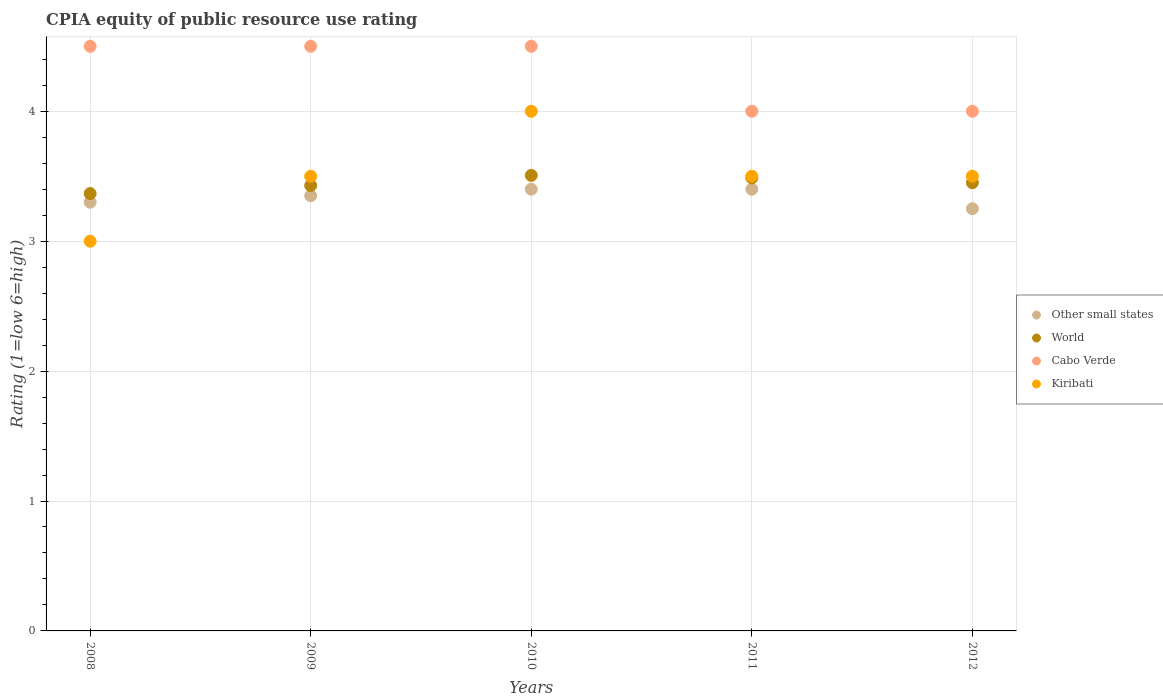Across all years, what is the minimum CPIA rating in Kiribati?
Your answer should be very brief. 3. In which year was the CPIA rating in Other small states minimum?
Make the answer very short. 2012. What is the total CPIA rating in World in the graph?
Offer a very short reply. 17.24. What is the difference between the CPIA rating in World in 2010 and that in 2012?
Make the answer very short. 0.06. What is the difference between the CPIA rating in World in 2010 and the CPIA rating in Kiribati in 2009?
Ensure brevity in your answer.  0.01. In the year 2009, what is the difference between the CPIA rating in World and CPIA rating in Other small states?
Keep it short and to the point. 0.08. In how many years, is the CPIA rating in Kiribati greater than 3.4?
Offer a terse response. 4. What is the ratio of the CPIA rating in Other small states in 2008 to that in 2011?
Provide a succinct answer. 0.97. What is the difference between the highest and the lowest CPIA rating in Cabo Verde?
Your answer should be compact. 0.5. In how many years, is the CPIA rating in Kiribati greater than the average CPIA rating in Kiribati taken over all years?
Give a very brief answer. 1. Is the sum of the CPIA rating in World in 2008 and 2012 greater than the maximum CPIA rating in Other small states across all years?
Your response must be concise. Yes. Is it the case that in every year, the sum of the CPIA rating in Other small states and CPIA rating in World  is greater than the sum of CPIA rating in Cabo Verde and CPIA rating in Kiribati?
Your response must be concise. No. Is it the case that in every year, the sum of the CPIA rating in World and CPIA rating in Kiribati  is greater than the CPIA rating in Other small states?
Your answer should be very brief. Yes. Does the CPIA rating in Kiribati monotonically increase over the years?
Your response must be concise. No. Is the CPIA rating in Other small states strictly greater than the CPIA rating in World over the years?
Your answer should be very brief. No. How many dotlines are there?
Provide a short and direct response. 4. What is the difference between two consecutive major ticks on the Y-axis?
Ensure brevity in your answer.  1. Are the values on the major ticks of Y-axis written in scientific E-notation?
Make the answer very short. No. Does the graph contain any zero values?
Your response must be concise. No. Does the graph contain grids?
Offer a very short reply. Yes. Where does the legend appear in the graph?
Provide a succinct answer. Center right. How are the legend labels stacked?
Your answer should be very brief. Vertical. What is the title of the graph?
Make the answer very short. CPIA equity of public resource use rating. Does "Angola" appear as one of the legend labels in the graph?
Offer a very short reply. No. What is the label or title of the X-axis?
Make the answer very short. Years. What is the label or title of the Y-axis?
Your response must be concise. Rating (1=low 6=high). What is the Rating (1=low 6=high) in World in 2008?
Provide a short and direct response. 3.37. What is the Rating (1=low 6=high) in Cabo Verde in 2008?
Keep it short and to the point. 4.5. What is the Rating (1=low 6=high) of Kiribati in 2008?
Keep it short and to the point. 3. What is the Rating (1=low 6=high) in Other small states in 2009?
Keep it short and to the point. 3.35. What is the Rating (1=low 6=high) of World in 2009?
Make the answer very short. 3.43. What is the Rating (1=low 6=high) in Cabo Verde in 2009?
Ensure brevity in your answer.  4.5. What is the Rating (1=low 6=high) of Other small states in 2010?
Provide a short and direct response. 3.4. What is the Rating (1=low 6=high) in World in 2010?
Offer a terse response. 3.51. What is the Rating (1=low 6=high) of Kiribati in 2010?
Your response must be concise. 4. What is the Rating (1=low 6=high) of Other small states in 2011?
Your answer should be very brief. 3.4. What is the Rating (1=low 6=high) in World in 2011?
Keep it short and to the point. 3.49. What is the Rating (1=low 6=high) of Cabo Verde in 2011?
Your answer should be compact. 4. What is the Rating (1=low 6=high) of World in 2012?
Your response must be concise. 3.45. What is the Rating (1=low 6=high) in Cabo Verde in 2012?
Offer a terse response. 4. What is the Rating (1=low 6=high) of Kiribati in 2012?
Give a very brief answer. 3.5. Across all years, what is the maximum Rating (1=low 6=high) of Other small states?
Ensure brevity in your answer.  3.4. Across all years, what is the maximum Rating (1=low 6=high) in World?
Make the answer very short. 3.51. Across all years, what is the maximum Rating (1=low 6=high) in Cabo Verde?
Make the answer very short. 4.5. Across all years, what is the minimum Rating (1=low 6=high) of World?
Your response must be concise. 3.37. Across all years, what is the minimum Rating (1=low 6=high) of Cabo Verde?
Your answer should be very brief. 4. Across all years, what is the minimum Rating (1=low 6=high) in Kiribati?
Provide a short and direct response. 3. What is the total Rating (1=low 6=high) in World in the graph?
Offer a terse response. 17.24. What is the difference between the Rating (1=low 6=high) of Other small states in 2008 and that in 2009?
Ensure brevity in your answer.  -0.05. What is the difference between the Rating (1=low 6=high) of World in 2008 and that in 2009?
Your answer should be very brief. -0.06. What is the difference between the Rating (1=low 6=high) of Cabo Verde in 2008 and that in 2009?
Make the answer very short. 0. What is the difference between the Rating (1=low 6=high) of Kiribati in 2008 and that in 2009?
Offer a very short reply. -0.5. What is the difference between the Rating (1=low 6=high) in World in 2008 and that in 2010?
Your answer should be very brief. -0.14. What is the difference between the Rating (1=low 6=high) of Cabo Verde in 2008 and that in 2010?
Your response must be concise. 0. What is the difference between the Rating (1=low 6=high) of World in 2008 and that in 2011?
Offer a terse response. -0.12. What is the difference between the Rating (1=low 6=high) in Cabo Verde in 2008 and that in 2011?
Give a very brief answer. 0.5. What is the difference between the Rating (1=low 6=high) of World in 2008 and that in 2012?
Offer a very short reply. -0.08. What is the difference between the Rating (1=low 6=high) of World in 2009 and that in 2010?
Your response must be concise. -0.08. What is the difference between the Rating (1=low 6=high) in Kiribati in 2009 and that in 2010?
Your answer should be very brief. -0.5. What is the difference between the Rating (1=low 6=high) of World in 2009 and that in 2011?
Your response must be concise. -0.06. What is the difference between the Rating (1=low 6=high) in Cabo Verde in 2009 and that in 2011?
Provide a succinct answer. 0.5. What is the difference between the Rating (1=low 6=high) of Other small states in 2009 and that in 2012?
Offer a terse response. 0.1. What is the difference between the Rating (1=low 6=high) of World in 2009 and that in 2012?
Your answer should be compact. -0.02. What is the difference between the Rating (1=low 6=high) of Cabo Verde in 2009 and that in 2012?
Offer a terse response. 0.5. What is the difference between the Rating (1=low 6=high) in Kiribati in 2009 and that in 2012?
Give a very brief answer. 0. What is the difference between the Rating (1=low 6=high) in Other small states in 2010 and that in 2011?
Offer a very short reply. 0. What is the difference between the Rating (1=low 6=high) of World in 2010 and that in 2011?
Provide a short and direct response. 0.02. What is the difference between the Rating (1=low 6=high) of Cabo Verde in 2010 and that in 2011?
Your answer should be compact. 0.5. What is the difference between the Rating (1=low 6=high) in Kiribati in 2010 and that in 2011?
Keep it short and to the point. 0.5. What is the difference between the Rating (1=low 6=high) in Other small states in 2010 and that in 2012?
Provide a succinct answer. 0.15. What is the difference between the Rating (1=low 6=high) in World in 2010 and that in 2012?
Your response must be concise. 0.06. What is the difference between the Rating (1=low 6=high) of Other small states in 2011 and that in 2012?
Provide a short and direct response. 0.15. What is the difference between the Rating (1=low 6=high) of World in 2011 and that in 2012?
Make the answer very short. 0.04. What is the difference between the Rating (1=low 6=high) in Cabo Verde in 2011 and that in 2012?
Your answer should be very brief. 0. What is the difference between the Rating (1=low 6=high) in Kiribati in 2011 and that in 2012?
Your response must be concise. 0. What is the difference between the Rating (1=low 6=high) of Other small states in 2008 and the Rating (1=low 6=high) of World in 2009?
Make the answer very short. -0.13. What is the difference between the Rating (1=low 6=high) in Other small states in 2008 and the Rating (1=low 6=high) in Cabo Verde in 2009?
Offer a terse response. -1.2. What is the difference between the Rating (1=low 6=high) in World in 2008 and the Rating (1=low 6=high) in Cabo Verde in 2009?
Provide a short and direct response. -1.13. What is the difference between the Rating (1=low 6=high) in World in 2008 and the Rating (1=low 6=high) in Kiribati in 2009?
Your answer should be compact. -0.13. What is the difference between the Rating (1=low 6=high) in Other small states in 2008 and the Rating (1=low 6=high) in World in 2010?
Your answer should be very brief. -0.21. What is the difference between the Rating (1=low 6=high) of Other small states in 2008 and the Rating (1=low 6=high) of Cabo Verde in 2010?
Offer a terse response. -1.2. What is the difference between the Rating (1=low 6=high) in World in 2008 and the Rating (1=low 6=high) in Cabo Verde in 2010?
Offer a terse response. -1.13. What is the difference between the Rating (1=low 6=high) in World in 2008 and the Rating (1=low 6=high) in Kiribati in 2010?
Give a very brief answer. -0.63. What is the difference between the Rating (1=low 6=high) in Other small states in 2008 and the Rating (1=low 6=high) in World in 2011?
Provide a short and direct response. -0.19. What is the difference between the Rating (1=low 6=high) in Other small states in 2008 and the Rating (1=low 6=high) in Cabo Verde in 2011?
Give a very brief answer. -0.7. What is the difference between the Rating (1=low 6=high) of Other small states in 2008 and the Rating (1=low 6=high) of Kiribati in 2011?
Your response must be concise. -0.2. What is the difference between the Rating (1=low 6=high) in World in 2008 and the Rating (1=low 6=high) in Cabo Verde in 2011?
Make the answer very short. -0.63. What is the difference between the Rating (1=low 6=high) in World in 2008 and the Rating (1=low 6=high) in Kiribati in 2011?
Offer a terse response. -0.13. What is the difference between the Rating (1=low 6=high) of Cabo Verde in 2008 and the Rating (1=low 6=high) of Kiribati in 2011?
Ensure brevity in your answer.  1. What is the difference between the Rating (1=low 6=high) in Other small states in 2008 and the Rating (1=low 6=high) in World in 2012?
Give a very brief answer. -0.15. What is the difference between the Rating (1=low 6=high) in Other small states in 2008 and the Rating (1=low 6=high) in Cabo Verde in 2012?
Ensure brevity in your answer.  -0.7. What is the difference between the Rating (1=low 6=high) in World in 2008 and the Rating (1=low 6=high) in Cabo Verde in 2012?
Your answer should be very brief. -0.63. What is the difference between the Rating (1=low 6=high) in World in 2008 and the Rating (1=low 6=high) in Kiribati in 2012?
Provide a short and direct response. -0.13. What is the difference between the Rating (1=low 6=high) of Cabo Verde in 2008 and the Rating (1=low 6=high) of Kiribati in 2012?
Offer a very short reply. 1. What is the difference between the Rating (1=low 6=high) of Other small states in 2009 and the Rating (1=low 6=high) of World in 2010?
Offer a very short reply. -0.16. What is the difference between the Rating (1=low 6=high) in Other small states in 2009 and the Rating (1=low 6=high) in Cabo Verde in 2010?
Provide a succinct answer. -1.15. What is the difference between the Rating (1=low 6=high) in Other small states in 2009 and the Rating (1=low 6=high) in Kiribati in 2010?
Your answer should be very brief. -0.65. What is the difference between the Rating (1=low 6=high) of World in 2009 and the Rating (1=low 6=high) of Cabo Verde in 2010?
Offer a terse response. -1.07. What is the difference between the Rating (1=low 6=high) of World in 2009 and the Rating (1=low 6=high) of Kiribati in 2010?
Ensure brevity in your answer.  -0.57. What is the difference between the Rating (1=low 6=high) of Other small states in 2009 and the Rating (1=low 6=high) of World in 2011?
Make the answer very short. -0.14. What is the difference between the Rating (1=low 6=high) in Other small states in 2009 and the Rating (1=low 6=high) in Cabo Verde in 2011?
Provide a succinct answer. -0.65. What is the difference between the Rating (1=low 6=high) of Other small states in 2009 and the Rating (1=low 6=high) of Kiribati in 2011?
Offer a very short reply. -0.15. What is the difference between the Rating (1=low 6=high) of World in 2009 and the Rating (1=low 6=high) of Cabo Verde in 2011?
Ensure brevity in your answer.  -0.57. What is the difference between the Rating (1=low 6=high) in World in 2009 and the Rating (1=low 6=high) in Kiribati in 2011?
Keep it short and to the point. -0.07. What is the difference between the Rating (1=low 6=high) in Cabo Verde in 2009 and the Rating (1=low 6=high) in Kiribati in 2011?
Keep it short and to the point. 1. What is the difference between the Rating (1=low 6=high) in Other small states in 2009 and the Rating (1=low 6=high) in Cabo Verde in 2012?
Your answer should be compact. -0.65. What is the difference between the Rating (1=low 6=high) in World in 2009 and the Rating (1=low 6=high) in Cabo Verde in 2012?
Your answer should be very brief. -0.57. What is the difference between the Rating (1=low 6=high) of World in 2009 and the Rating (1=low 6=high) of Kiribati in 2012?
Your response must be concise. -0.07. What is the difference between the Rating (1=low 6=high) in Cabo Verde in 2009 and the Rating (1=low 6=high) in Kiribati in 2012?
Make the answer very short. 1. What is the difference between the Rating (1=low 6=high) in Other small states in 2010 and the Rating (1=low 6=high) in World in 2011?
Your response must be concise. -0.09. What is the difference between the Rating (1=low 6=high) of World in 2010 and the Rating (1=low 6=high) of Cabo Verde in 2011?
Keep it short and to the point. -0.49. What is the difference between the Rating (1=low 6=high) in World in 2010 and the Rating (1=low 6=high) in Kiribati in 2011?
Offer a very short reply. 0.01. What is the difference between the Rating (1=low 6=high) of Cabo Verde in 2010 and the Rating (1=low 6=high) of Kiribati in 2011?
Your answer should be very brief. 1. What is the difference between the Rating (1=low 6=high) in Other small states in 2010 and the Rating (1=low 6=high) in Cabo Verde in 2012?
Offer a very short reply. -0.6. What is the difference between the Rating (1=low 6=high) of World in 2010 and the Rating (1=low 6=high) of Cabo Verde in 2012?
Give a very brief answer. -0.49. What is the difference between the Rating (1=low 6=high) of World in 2010 and the Rating (1=low 6=high) of Kiribati in 2012?
Give a very brief answer. 0.01. What is the difference between the Rating (1=low 6=high) in Other small states in 2011 and the Rating (1=low 6=high) in World in 2012?
Your response must be concise. -0.05. What is the difference between the Rating (1=low 6=high) in Other small states in 2011 and the Rating (1=low 6=high) in Cabo Verde in 2012?
Keep it short and to the point. -0.6. What is the difference between the Rating (1=low 6=high) in World in 2011 and the Rating (1=low 6=high) in Cabo Verde in 2012?
Your answer should be compact. -0.51. What is the difference between the Rating (1=low 6=high) of World in 2011 and the Rating (1=low 6=high) of Kiribati in 2012?
Offer a terse response. -0.01. What is the average Rating (1=low 6=high) in Other small states per year?
Your answer should be very brief. 3.34. What is the average Rating (1=low 6=high) of World per year?
Your answer should be compact. 3.45. What is the average Rating (1=low 6=high) of Cabo Verde per year?
Your response must be concise. 4.3. In the year 2008, what is the difference between the Rating (1=low 6=high) of Other small states and Rating (1=low 6=high) of World?
Give a very brief answer. -0.07. In the year 2008, what is the difference between the Rating (1=low 6=high) of Other small states and Rating (1=low 6=high) of Kiribati?
Make the answer very short. 0.3. In the year 2008, what is the difference between the Rating (1=low 6=high) in World and Rating (1=low 6=high) in Cabo Verde?
Keep it short and to the point. -1.13. In the year 2008, what is the difference between the Rating (1=low 6=high) in World and Rating (1=low 6=high) in Kiribati?
Provide a short and direct response. 0.37. In the year 2009, what is the difference between the Rating (1=low 6=high) of Other small states and Rating (1=low 6=high) of World?
Provide a short and direct response. -0.08. In the year 2009, what is the difference between the Rating (1=low 6=high) in Other small states and Rating (1=low 6=high) in Cabo Verde?
Your answer should be compact. -1.15. In the year 2009, what is the difference between the Rating (1=low 6=high) in Other small states and Rating (1=low 6=high) in Kiribati?
Offer a very short reply. -0.15. In the year 2009, what is the difference between the Rating (1=low 6=high) of World and Rating (1=low 6=high) of Cabo Verde?
Your answer should be compact. -1.07. In the year 2009, what is the difference between the Rating (1=low 6=high) of World and Rating (1=low 6=high) of Kiribati?
Your answer should be very brief. -0.07. In the year 2010, what is the difference between the Rating (1=low 6=high) in Other small states and Rating (1=low 6=high) in World?
Offer a terse response. -0.11. In the year 2010, what is the difference between the Rating (1=low 6=high) in Other small states and Rating (1=low 6=high) in Kiribati?
Your answer should be very brief. -0.6. In the year 2010, what is the difference between the Rating (1=low 6=high) of World and Rating (1=low 6=high) of Cabo Verde?
Make the answer very short. -0.99. In the year 2010, what is the difference between the Rating (1=low 6=high) in World and Rating (1=low 6=high) in Kiribati?
Your answer should be compact. -0.49. In the year 2011, what is the difference between the Rating (1=low 6=high) of Other small states and Rating (1=low 6=high) of World?
Provide a succinct answer. -0.09. In the year 2011, what is the difference between the Rating (1=low 6=high) in Other small states and Rating (1=low 6=high) in Kiribati?
Keep it short and to the point. -0.1. In the year 2011, what is the difference between the Rating (1=low 6=high) in World and Rating (1=low 6=high) in Cabo Verde?
Offer a terse response. -0.51. In the year 2011, what is the difference between the Rating (1=low 6=high) in World and Rating (1=low 6=high) in Kiribati?
Provide a short and direct response. -0.01. In the year 2011, what is the difference between the Rating (1=low 6=high) in Cabo Verde and Rating (1=low 6=high) in Kiribati?
Your response must be concise. 0.5. In the year 2012, what is the difference between the Rating (1=low 6=high) of Other small states and Rating (1=low 6=high) of Cabo Verde?
Keep it short and to the point. -0.75. In the year 2012, what is the difference between the Rating (1=low 6=high) in World and Rating (1=low 6=high) in Cabo Verde?
Give a very brief answer. -0.55. In the year 2012, what is the difference between the Rating (1=low 6=high) in Cabo Verde and Rating (1=low 6=high) in Kiribati?
Provide a succinct answer. 0.5. What is the ratio of the Rating (1=low 6=high) in Other small states in 2008 to that in 2009?
Provide a short and direct response. 0.99. What is the ratio of the Rating (1=low 6=high) of World in 2008 to that in 2009?
Ensure brevity in your answer.  0.98. What is the ratio of the Rating (1=low 6=high) in Cabo Verde in 2008 to that in 2009?
Your answer should be very brief. 1. What is the ratio of the Rating (1=low 6=high) of Kiribati in 2008 to that in 2009?
Offer a very short reply. 0.86. What is the ratio of the Rating (1=low 6=high) of Other small states in 2008 to that in 2010?
Your answer should be compact. 0.97. What is the ratio of the Rating (1=low 6=high) in World in 2008 to that in 2010?
Your answer should be compact. 0.96. What is the ratio of the Rating (1=low 6=high) of Kiribati in 2008 to that in 2010?
Make the answer very short. 0.75. What is the ratio of the Rating (1=low 6=high) of Other small states in 2008 to that in 2011?
Give a very brief answer. 0.97. What is the ratio of the Rating (1=low 6=high) of World in 2008 to that in 2011?
Your answer should be very brief. 0.97. What is the ratio of the Rating (1=low 6=high) in Other small states in 2008 to that in 2012?
Make the answer very short. 1.02. What is the ratio of the Rating (1=low 6=high) in World in 2008 to that in 2012?
Provide a succinct answer. 0.98. What is the ratio of the Rating (1=low 6=high) of Cabo Verde in 2008 to that in 2012?
Your answer should be compact. 1.12. What is the ratio of the Rating (1=low 6=high) of World in 2009 to that in 2010?
Offer a very short reply. 0.98. What is the ratio of the Rating (1=low 6=high) in Cabo Verde in 2009 to that in 2010?
Make the answer very short. 1. What is the ratio of the Rating (1=low 6=high) of World in 2009 to that in 2011?
Provide a succinct answer. 0.98. What is the ratio of the Rating (1=low 6=high) in Cabo Verde in 2009 to that in 2011?
Offer a terse response. 1.12. What is the ratio of the Rating (1=low 6=high) of Kiribati in 2009 to that in 2011?
Provide a short and direct response. 1. What is the ratio of the Rating (1=low 6=high) in Other small states in 2009 to that in 2012?
Your answer should be compact. 1.03. What is the ratio of the Rating (1=low 6=high) of Cabo Verde in 2009 to that in 2012?
Your answer should be very brief. 1.12. What is the ratio of the Rating (1=low 6=high) of Kiribati in 2010 to that in 2011?
Offer a terse response. 1.14. What is the ratio of the Rating (1=low 6=high) in Other small states in 2010 to that in 2012?
Give a very brief answer. 1.05. What is the ratio of the Rating (1=low 6=high) in World in 2010 to that in 2012?
Provide a short and direct response. 1.02. What is the ratio of the Rating (1=low 6=high) of Kiribati in 2010 to that in 2012?
Offer a very short reply. 1.14. What is the ratio of the Rating (1=low 6=high) in Other small states in 2011 to that in 2012?
Your response must be concise. 1.05. What is the ratio of the Rating (1=low 6=high) in World in 2011 to that in 2012?
Make the answer very short. 1.01. What is the difference between the highest and the second highest Rating (1=low 6=high) of World?
Provide a short and direct response. 0.02. What is the difference between the highest and the second highest Rating (1=low 6=high) of Kiribati?
Provide a short and direct response. 0.5. What is the difference between the highest and the lowest Rating (1=low 6=high) in Other small states?
Provide a short and direct response. 0.15. What is the difference between the highest and the lowest Rating (1=low 6=high) of World?
Offer a very short reply. 0.14. What is the difference between the highest and the lowest Rating (1=low 6=high) of Kiribati?
Make the answer very short. 1. 